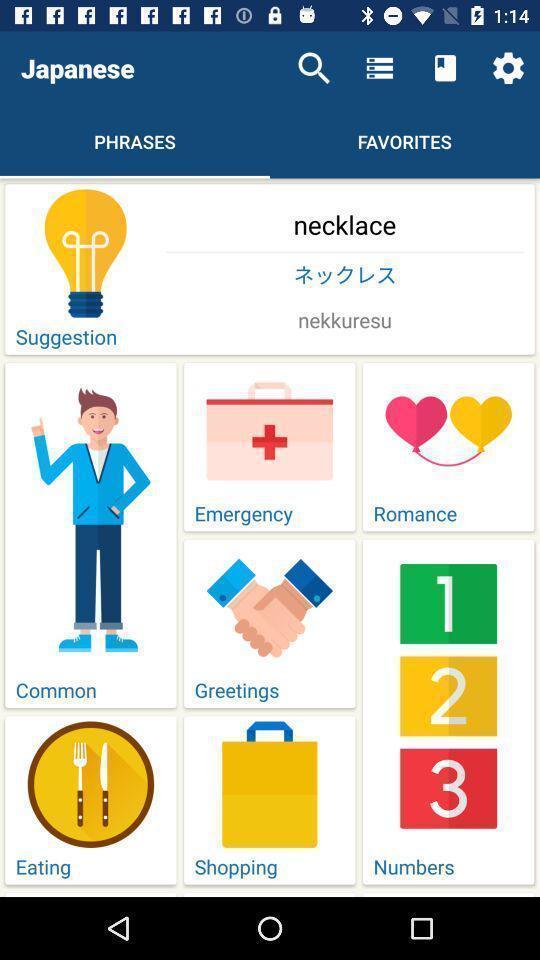Give me a summary of this screen capture. Screen displaying the phrases page with different categories. 